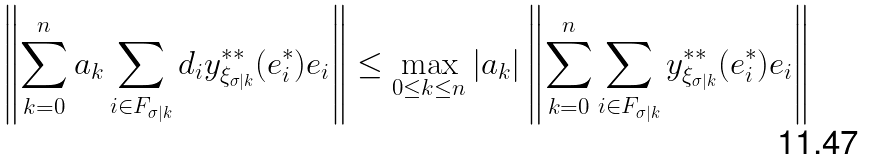<formula> <loc_0><loc_0><loc_500><loc_500>\left \| \sum _ { k = 0 } ^ { n } a _ { k } \sum _ { i \in F _ { \sigma | k } } d _ { i } y ^ { * * } _ { \xi _ { \sigma | k } } ( e _ { i } ^ { * } ) e _ { i } \right \| & \leq \max _ { 0 \leq k \leq n } | a _ { k } | \left \| \sum _ { k = 0 } ^ { n } \sum _ { i \in F _ { \sigma | k } } y ^ { * * } _ { \xi _ { \sigma | k } } ( e _ { i } ^ { * } ) e _ { i } \right \|</formula> 